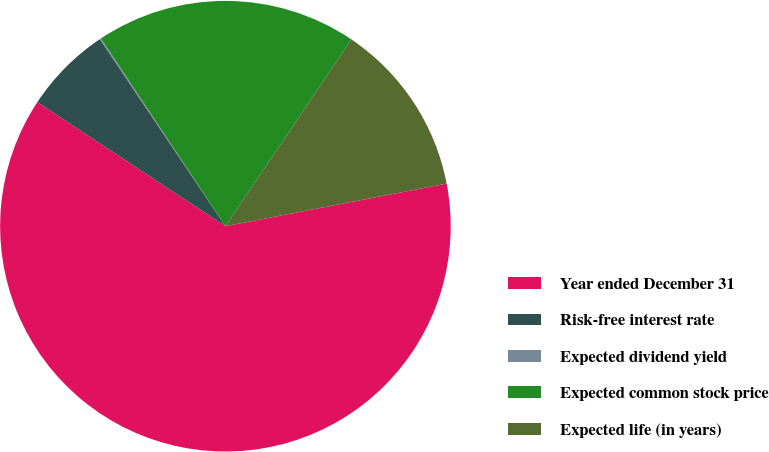<chart> <loc_0><loc_0><loc_500><loc_500><pie_chart><fcel>Year ended December 31<fcel>Risk-free interest rate<fcel>Expected dividend yield<fcel>Expected common stock price<fcel>Expected life (in years)<nl><fcel>62.31%<fcel>6.31%<fcel>0.09%<fcel>18.76%<fcel>12.53%<nl></chart> 